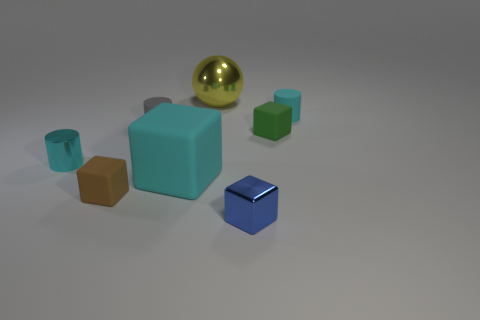Subtract 1 cubes. How many cubes are left? 3 Add 1 red metal blocks. How many objects exist? 9 Subtract all balls. How many objects are left? 7 Subtract all gray objects. Subtract all brown cubes. How many objects are left? 6 Add 1 tiny cyan matte cylinders. How many tiny cyan matte cylinders are left? 2 Add 4 large red shiny balls. How many large red shiny balls exist? 4 Subtract 0 yellow cylinders. How many objects are left? 8 